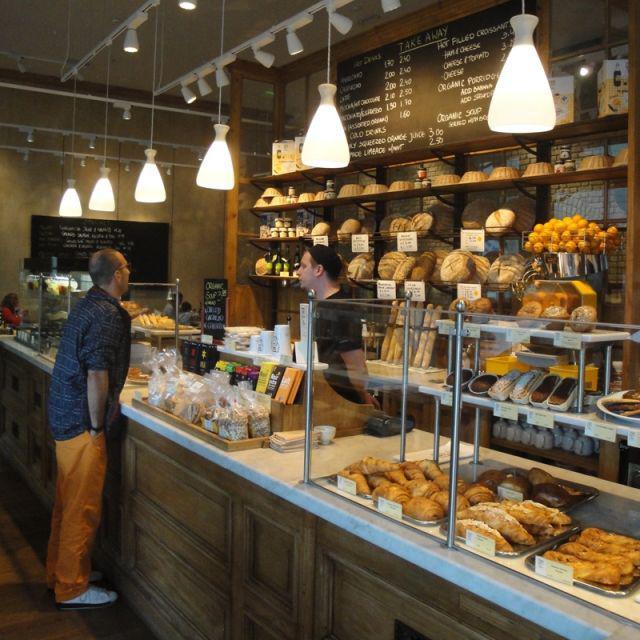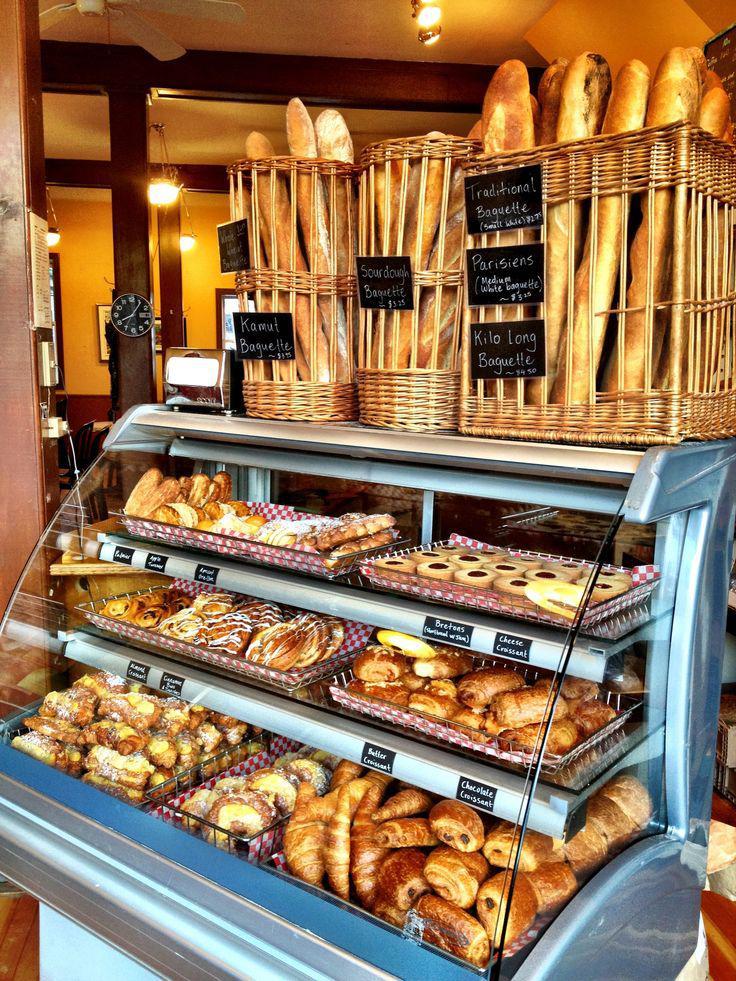The first image is the image on the left, the second image is the image on the right. Considering the images on both sides, is "The left image features at least one pendant light in the bakery." valid? Answer yes or no. Yes. The first image is the image on the left, the second image is the image on the right. Examine the images to the left and right. Is the description "There are baked goods in baskets in one of the images." accurate? Answer yes or no. Yes. 